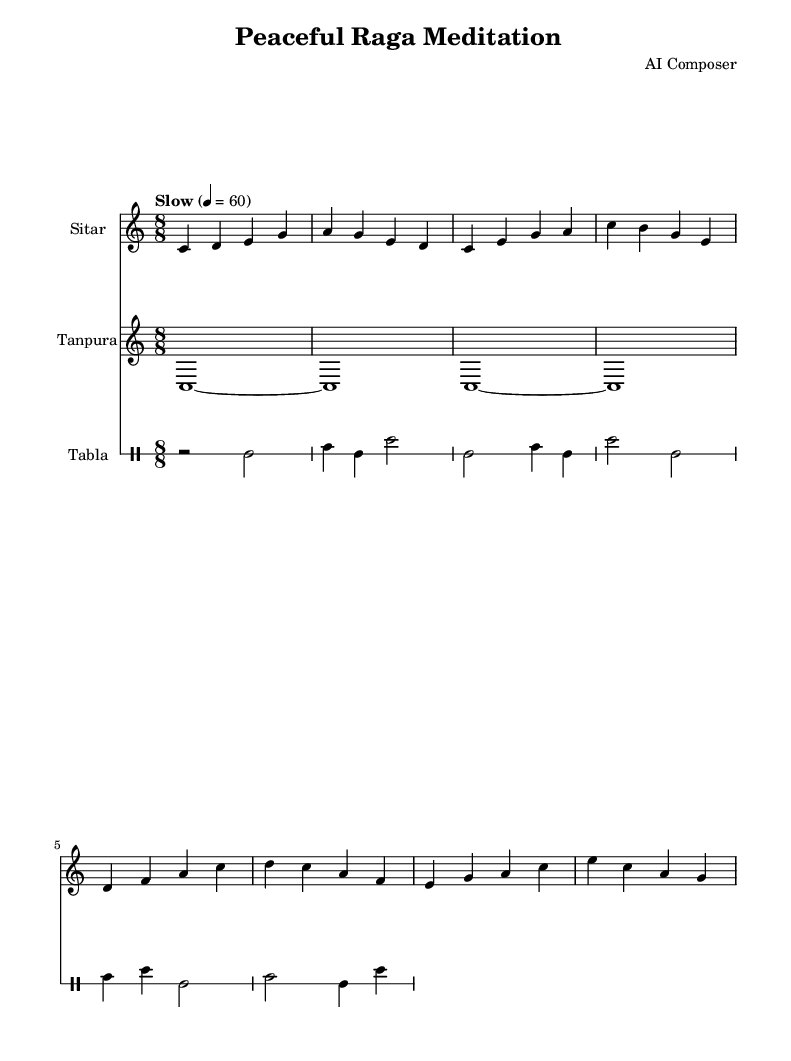What is the key signature of this music? The key signature indicated is C major, which is represented by no sharps or flats in the key signature at the beginning of the staff.
Answer: C major What is the time signature of the piece? The time signature shown is 8/8, which appears at the beginning of the score and indicates that there are eight beats in a measure, with the eighth note receiving one beat.
Answer: 8/8 What is the tempo marking for this music? The tempo marking is "Slow" with a metronome marking of 60, which describes the pace at which the music should be played. The indication is located above the staff.
Answer: Slow How many measures does the sitar part have? The sitar part in the provided music consists of four measures, which can be counted from the notation presented in the score labeled "sitar."
Answer: 4 What instruments are included in this score? The score includes three instruments: sitar, tanpura, and tabla, each labeled at the beginning of their respective staves.
Answer: Sitar, Tanpura, Tabla Which instrument has the longest note duration? The tanpura has the longest note duration with a whole note that is sustained for the entire measure, indicated by the use of a tied whole note.
Answer: Tanpura 